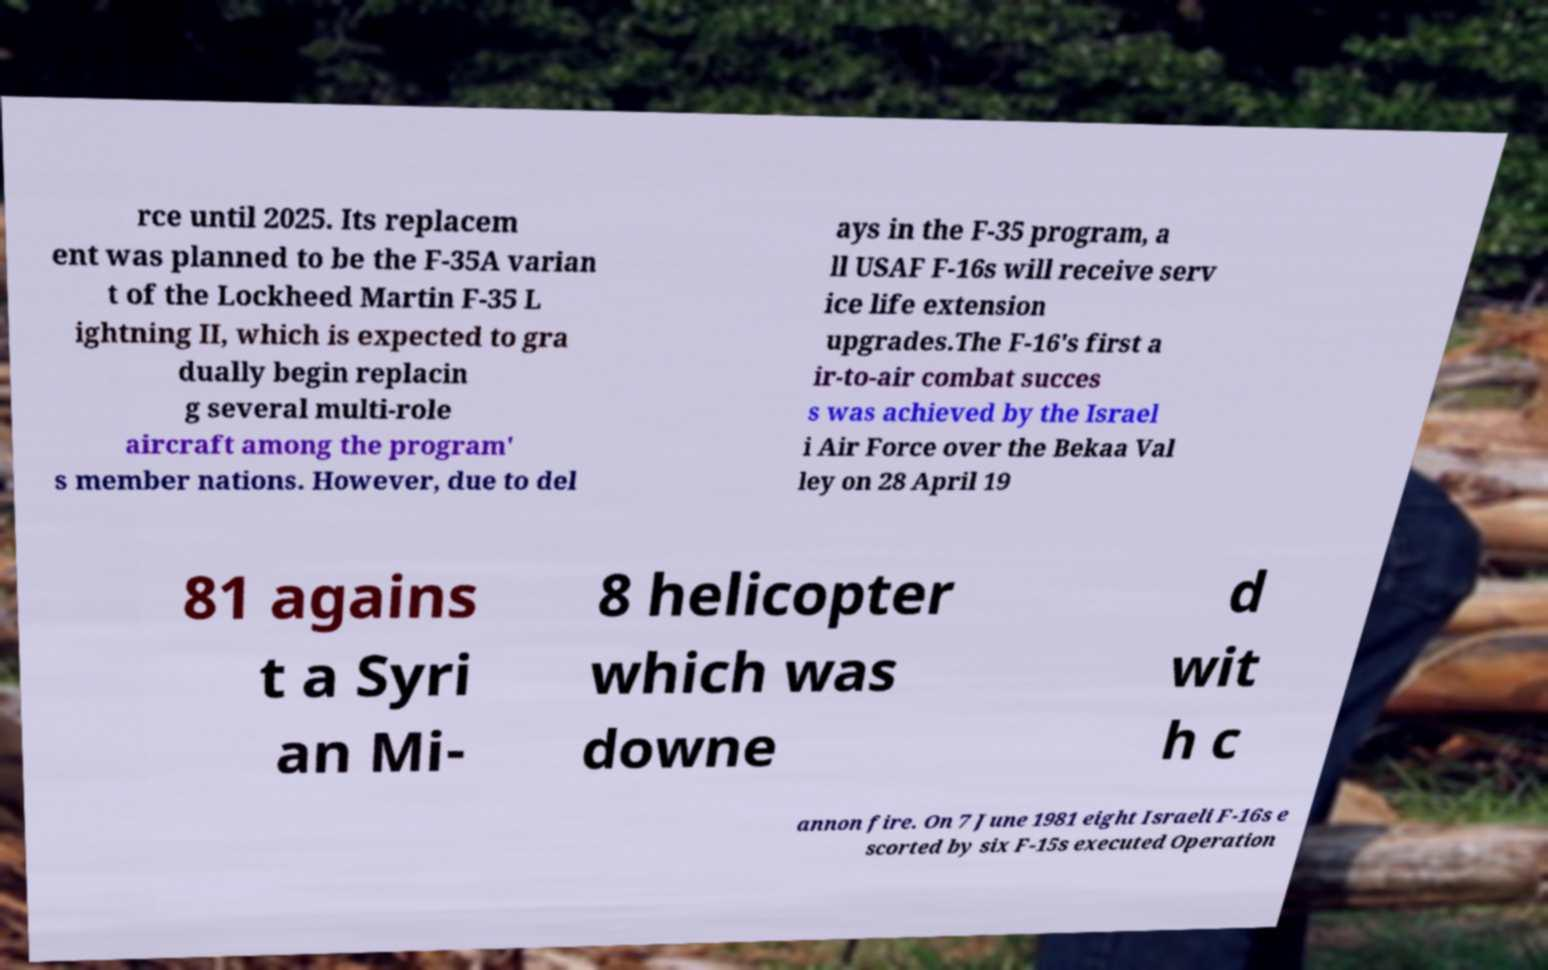Could you extract and type out the text from this image? rce until 2025. Its replacem ent was planned to be the F-35A varian t of the Lockheed Martin F-35 L ightning II, which is expected to gra dually begin replacin g several multi-role aircraft among the program' s member nations. However, due to del ays in the F-35 program, a ll USAF F-16s will receive serv ice life extension upgrades.The F-16's first a ir-to-air combat succes s was achieved by the Israel i Air Force over the Bekaa Val ley on 28 April 19 81 agains t a Syri an Mi- 8 helicopter which was downe d wit h c annon fire. On 7 June 1981 eight Israeli F-16s e scorted by six F-15s executed Operation 